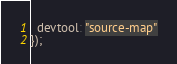Convert code to text. <code><loc_0><loc_0><loc_500><loc_500><_JavaScript_>  devtool: "source-map"
});
</code> 